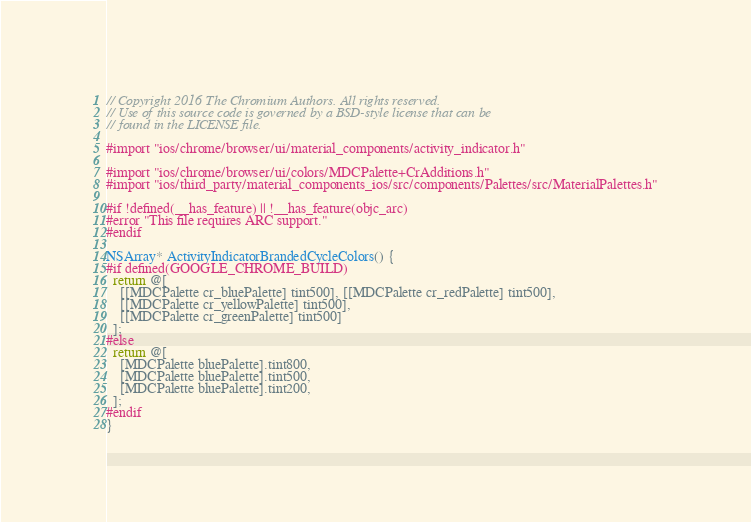<code> <loc_0><loc_0><loc_500><loc_500><_ObjectiveC_>// Copyright 2016 The Chromium Authors. All rights reserved.
// Use of this source code is governed by a BSD-style license that can be
// found in the LICENSE file.

#import "ios/chrome/browser/ui/material_components/activity_indicator.h"

#import "ios/chrome/browser/ui/colors/MDCPalette+CrAdditions.h"
#import "ios/third_party/material_components_ios/src/components/Palettes/src/MaterialPalettes.h"

#if !defined(__has_feature) || !__has_feature(objc_arc)
#error "This file requires ARC support."
#endif

NSArray* ActivityIndicatorBrandedCycleColors() {
#if defined(GOOGLE_CHROME_BUILD)
  return @[
    [[MDCPalette cr_bluePalette] tint500], [[MDCPalette cr_redPalette] tint500],
    [[MDCPalette cr_yellowPalette] tint500],
    [[MDCPalette cr_greenPalette] tint500]
  ];
#else
  return @[
    [MDCPalette bluePalette].tint800,
    [MDCPalette bluePalette].tint500,
    [MDCPalette bluePalette].tint200,
  ];
#endif
}
</code> 